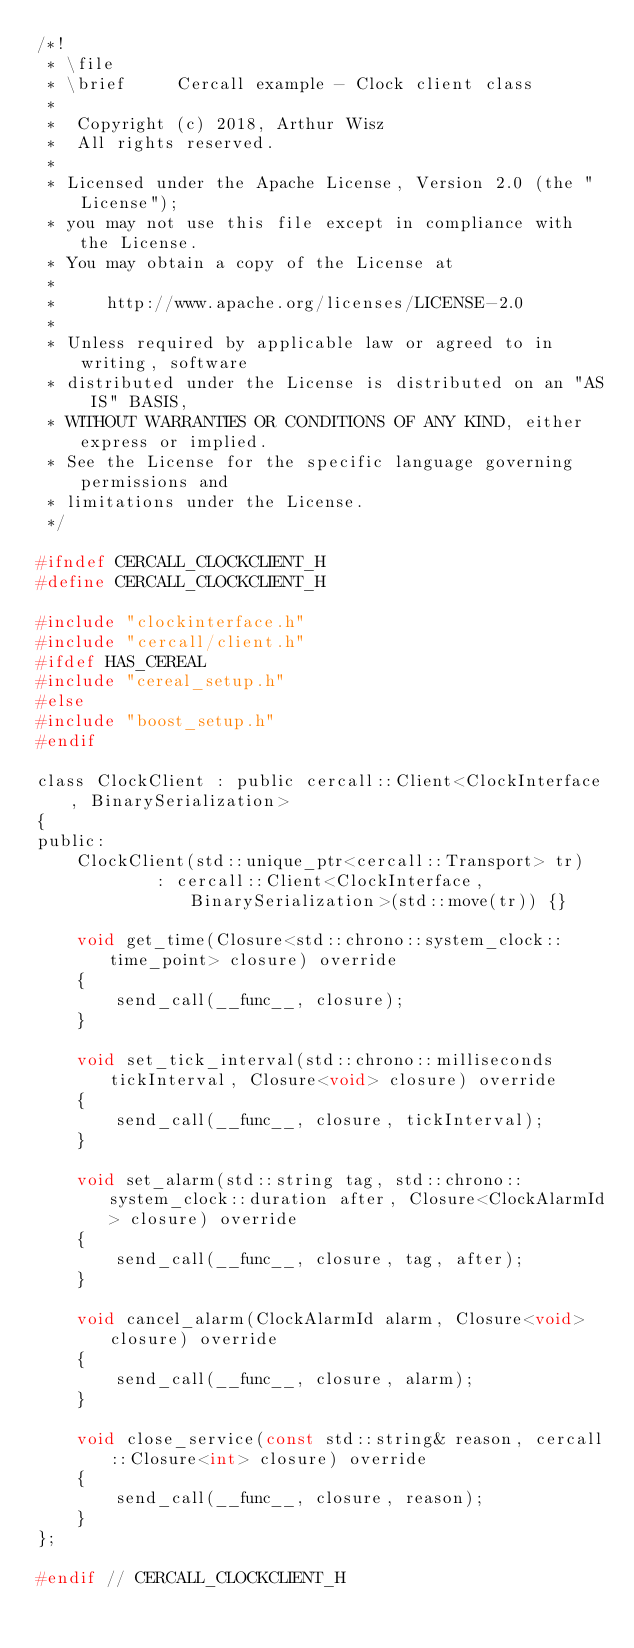<code> <loc_0><loc_0><loc_500><loc_500><_C_>/*!
 * \file
 * \brief     Cercall example - Clock client class
 *
 *  Copyright (c) 2018, Arthur Wisz
 *  All rights reserved.
 *
 * Licensed under the Apache License, Version 2.0 (the "License");
 * you may not use this file except in compliance with the License.
 * You may obtain a copy of the License at
 *
 *     http://www.apache.org/licenses/LICENSE-2.0
 *
 * Unless required by applicable law or agreed to in writing, software
 * distributed under the License is distributed on an "AS IS" BASIS,
 * WITHOUT WARRANTIES OR CONDITIONS OF ANY KIND, either express or implied.
 * See the License for the specific language governing permissions and
 * limitations under the License.
 */

#ifndef CERCALL_CLOCKCLIENT_H
#define CERCALL_CLOCKCLIENT_H

#include "clockinterface.h"
#include "cercall/client.h"
#ifdef HAS_CEREAL
#include "cereal_setup.h"
#else
#include "boost_setup.h"
#endif

class ClockClient : public cercall::Client<ClockInterface, BinarySerialization>
{
public:
    ClockClient(std::unique_ptr<cercall::Transport> tr)
            : cercall::Client<ClockInterface, BinarySerialization>(std::move(tr)) {}

    void get_time(Closure<std::chrono::system_clock::time_point> closure) override
    {
        send_call(__func__, closure);
    }

    void set_tick_interval(std::chrono::milliseconds tickInterval, Closure<void> closure) override
    {
        send_call(__func__, closure, tickInterval);
    }

    void set_alarm(std::string tag, std::chrono::system_clock::duration after, Closure<ClockAlarmId> closure) override
    {
        send_call(__func__, closure, tag, after);
    }

    void cancel_alarm(ClockAlarmId alarm, Closure<void> closure) override
    {
        send_call(__func__, closure, alarm);
    }

    void close_service(const std::string& reason, cercall::Closure<int> closure) override
    {
        send_call(__func__, closure, reason);
    }
};

#endif // CERCALL_CLOCKCLIENT_H
</code> 